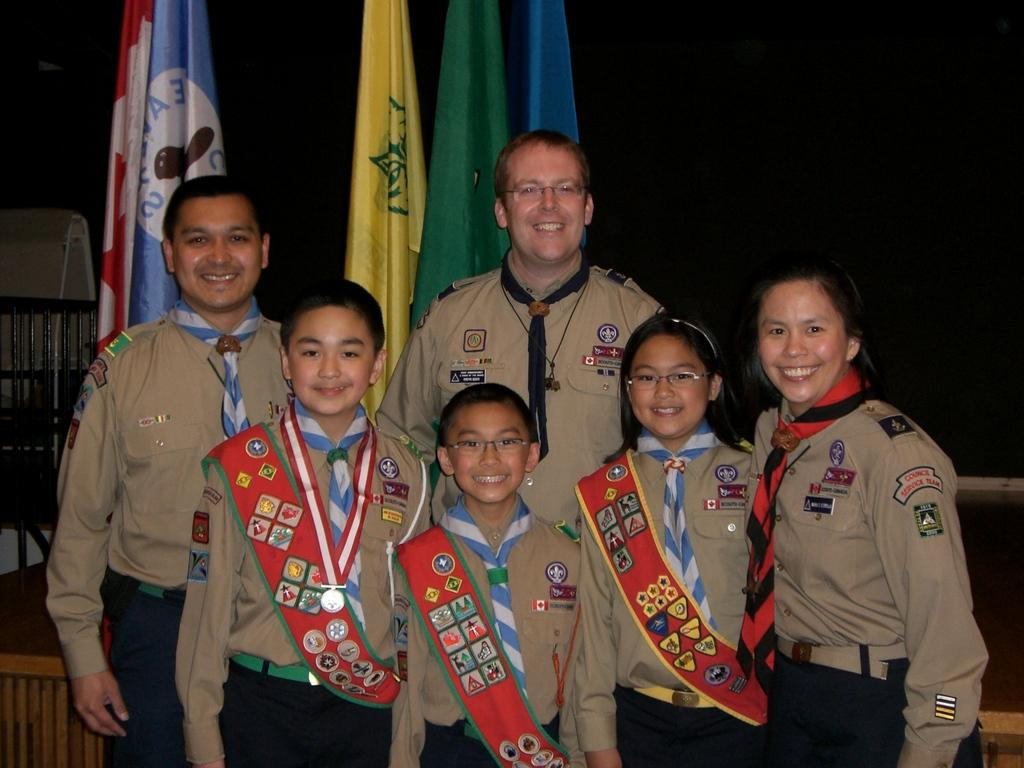How many adults are in the image? There are two men and one woman in the image, making a total of three adults. How many children are in the image? There are three children in the image. What are the individuals wearing? The individuals are wearing uniforms. What expressions do the individuals have? The individuals are smiling. What can be seen in the background of the image? There is a part of railing visible in the background of the image. How would you describe the lighting in the image? The background of the image is dark. Can you see any nests in the image? There are no nests present in the image. What color is the knee of the woman in the image? The image does not provide enough detail to determine the color of the woman's knee. 